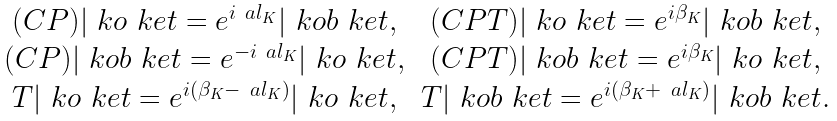Convert formula to latex. <formula><loc_0><loc_0><loc_500><loc_500>\begin{array} { c c } ( C P ) | \ k o \ k e t = e ^ { i \ a l _ { K } } | \ k o b \ k e t , & ( C P T ) | \ k o \ k e t = e ^ { i \beta _ { K } } | \ k o b \ k e t , \\ ( C P ) | \ k o b \ k e t = e ^ { - i \ a l _ { K } } | \ k o \ k e t , & ( C P T ) | \ k o b \ k e t = e ^ { i \beta _ { K } } | \ k o \ k e t , \\ T | \ k o \ k e t = e ^ { i ( \beta _ { K } - \ a l _ { K } ) } | \ k o \ k e t , & T | \ k o b \ k e t = e ^ { i ( \beta _ { K } + \ a l _ { K } ) } | \ k o b \ k e t . \end{array}</formula> 